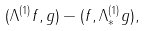<formula> <loc_0><loc_0><loc_500><loc_500>( \Lambda ^ { ( 1 ) } f , g ) - ( f , \Lambda _ { * } ^ { ( 1 ) } g ) ,</formula> 